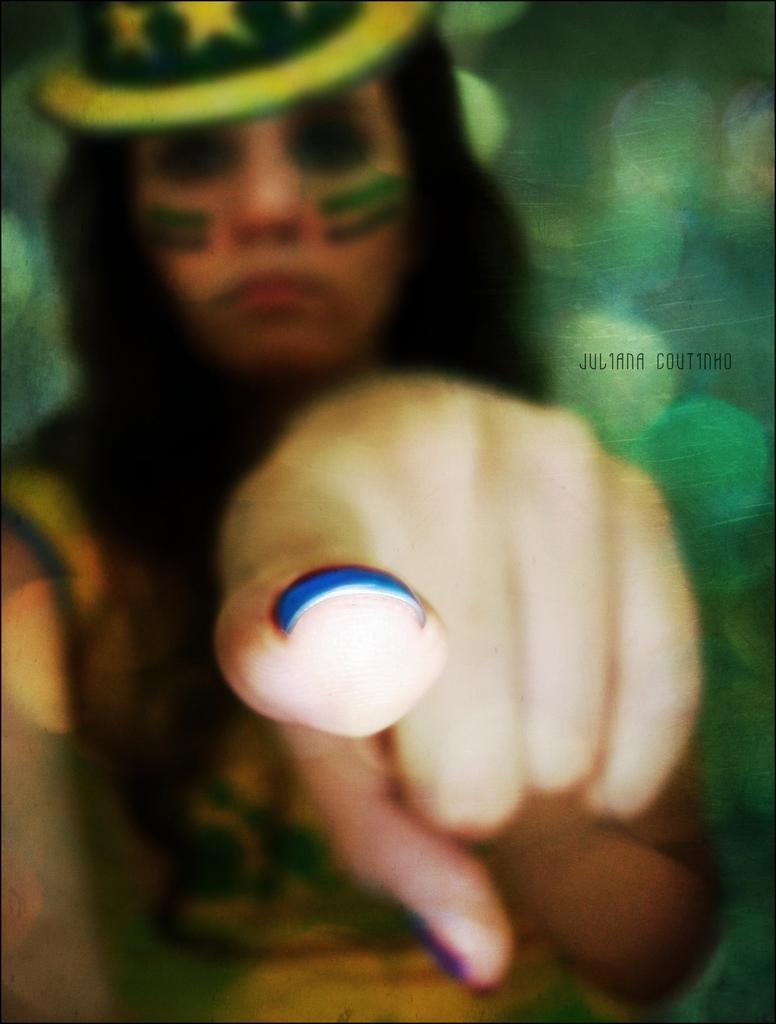Describe this image in one or two sentences. In this picture we observe a lady who is pointing her finger to the camera. 